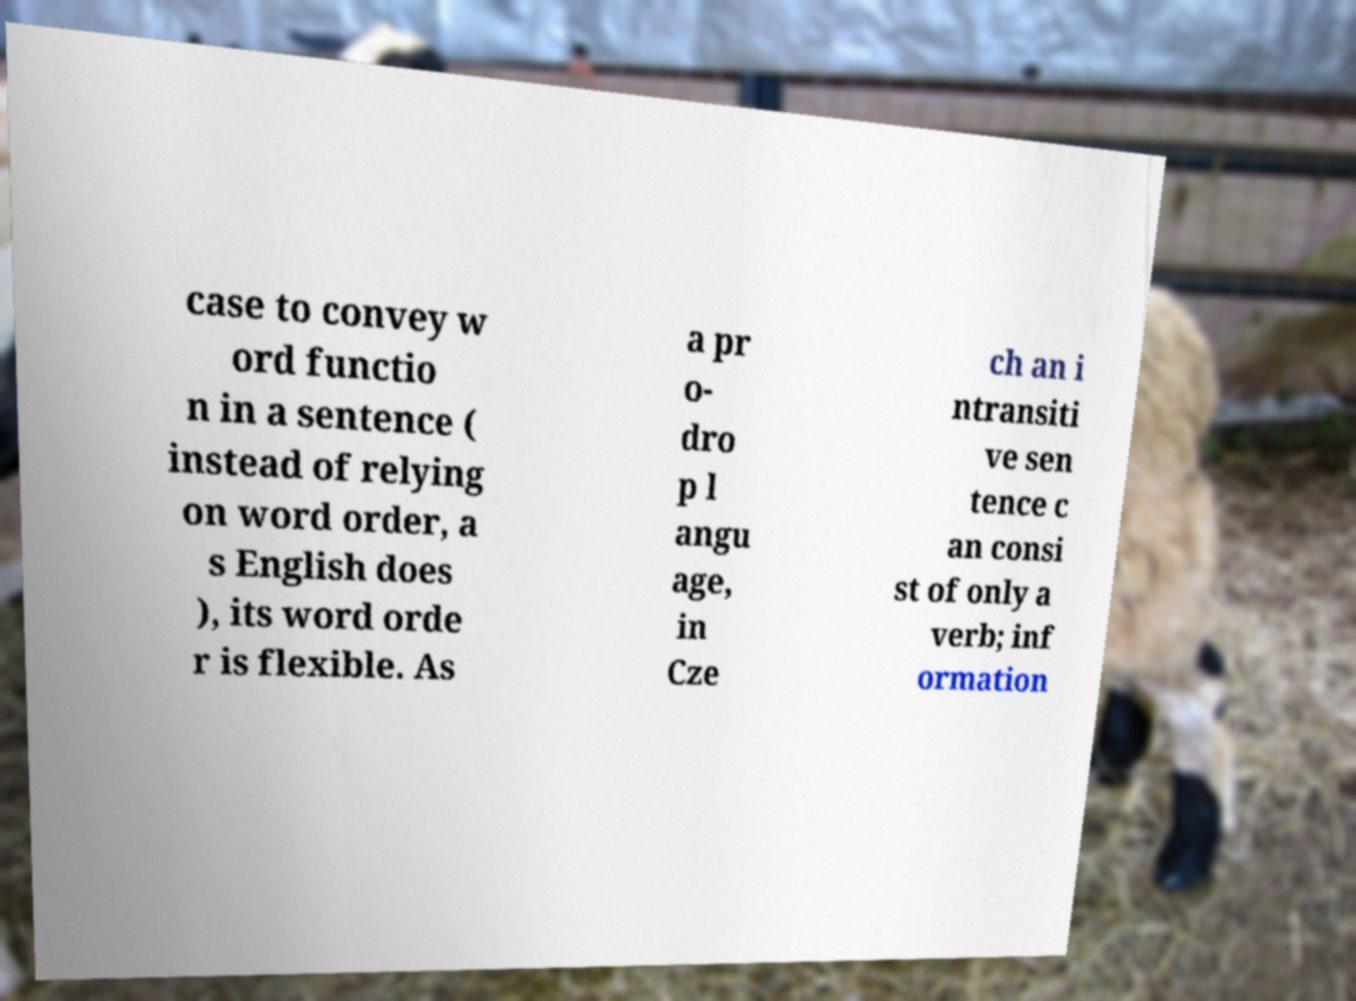Can you accurately transcribe the text from the provided image for me? case to convey w ord functio n in a sentence ( instead of relying on word order, a s English does ), its word orde r is flexible. As a pr o- dro p l angu age, in Cze ch an i ntransiti ve sen tence c an consi st of only a verb; inf ormation 